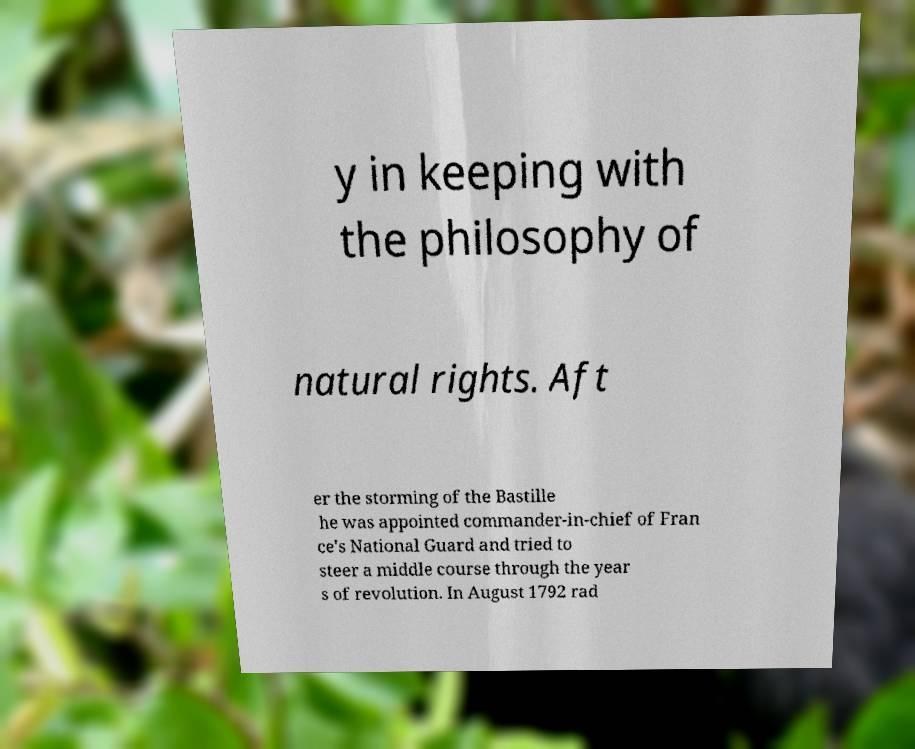There's text embedded in this image that I need extracted. Can you transcribe it verbatim? y in keeping with the philosophy of natural rights. Aft er the storming of the Bastille he was appointed commander-in-chief of Fran ce's National Guard and tried to steer a middle course through the year s of revolution. In August 1792 rad 